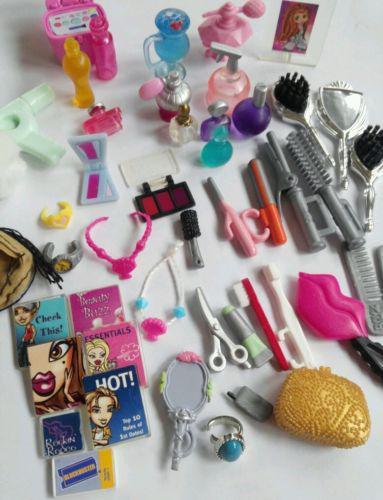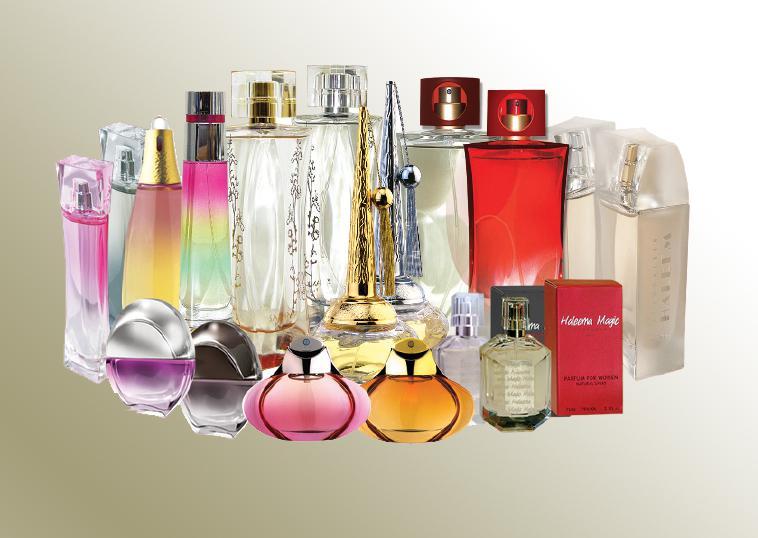The first image is the image on the left, the second image is the image on the right. Analyze the images presented: Is the assertion "All products are standing upright." valid? Answer yes or no. No. The first image is the image on the left, the second image is the image on the right. Evaluate the accuracy of this statement regarding the images: "One image includes a row of at least three clear glass fragrance bottles with tall metallic caps, and the other image includes several roundish bottles with round caps.". Is it true? Answer yes or no. No. 